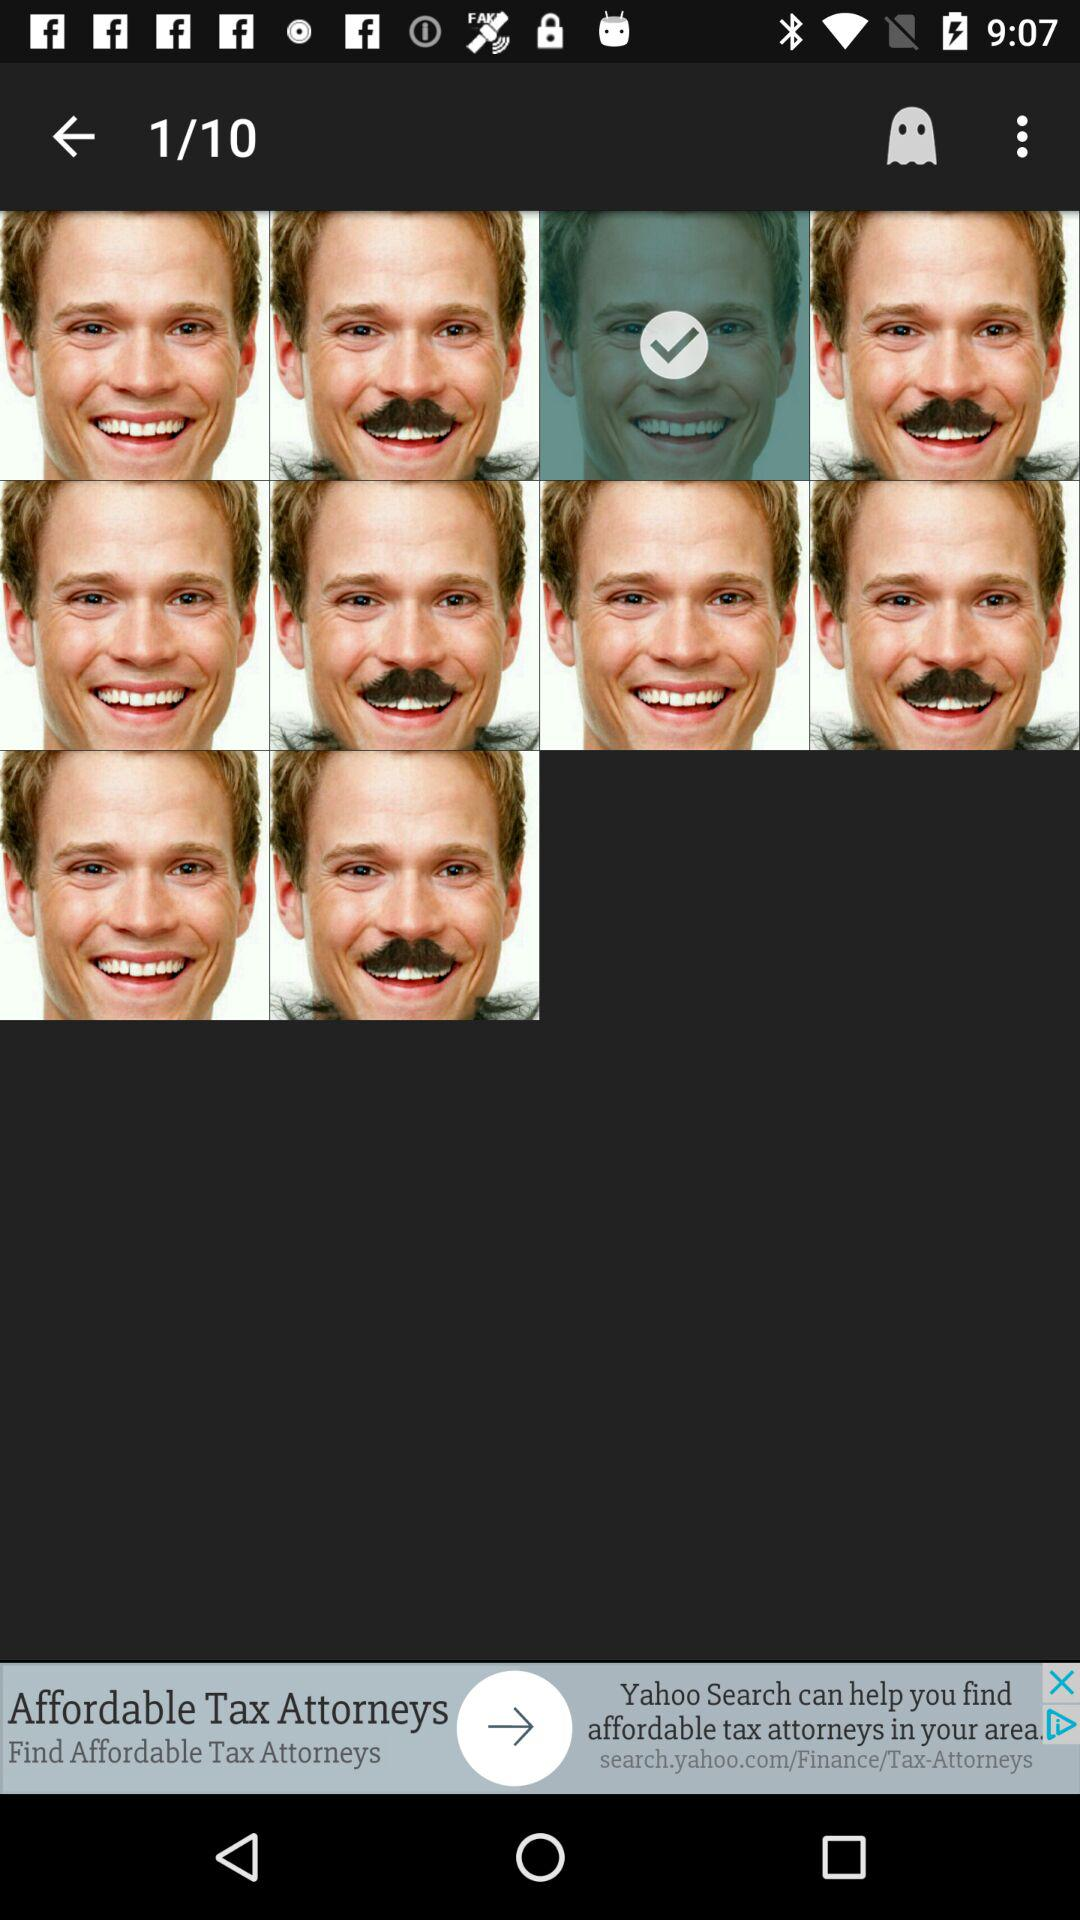What is the selected checkbox?
When the provided information is insufficient, respond with <no answer>. <no answer> 